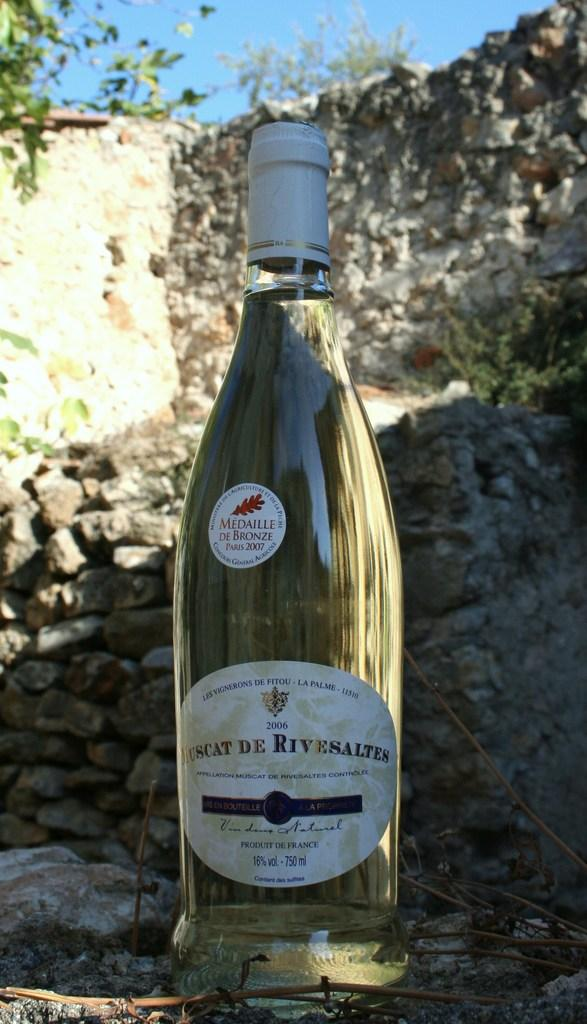<image>
Share a concise interpretation of the image provided. A bottle of Scat De Rivesaltes is shown in front of a mountain. 